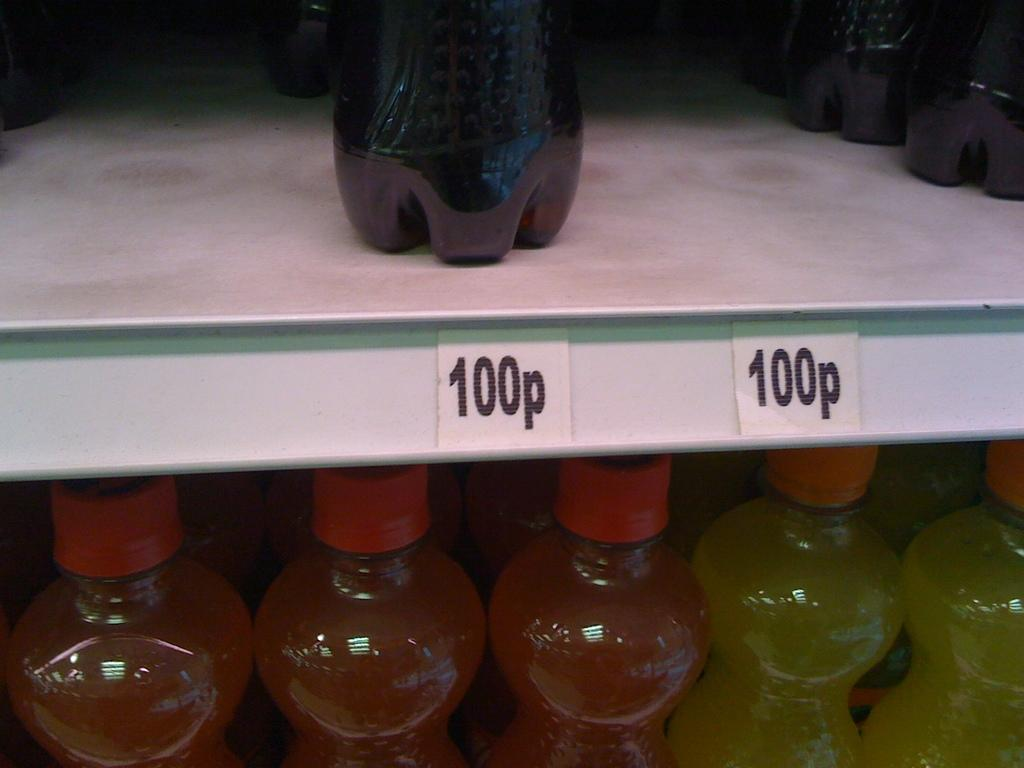What objects are present in the image? There are bottles in the image. Can you describe the colors of the bottles? The bottles are orange, yellow, and black in color. How are the bottles arranged in the image? The bottles are in racks. Are there any additional details visible on the bottles? Yes, there are price tags visible in the image. Can you see a collar on the giraffe in the image? There is no giraffe present in the image, and therefore no collar can be seen. 